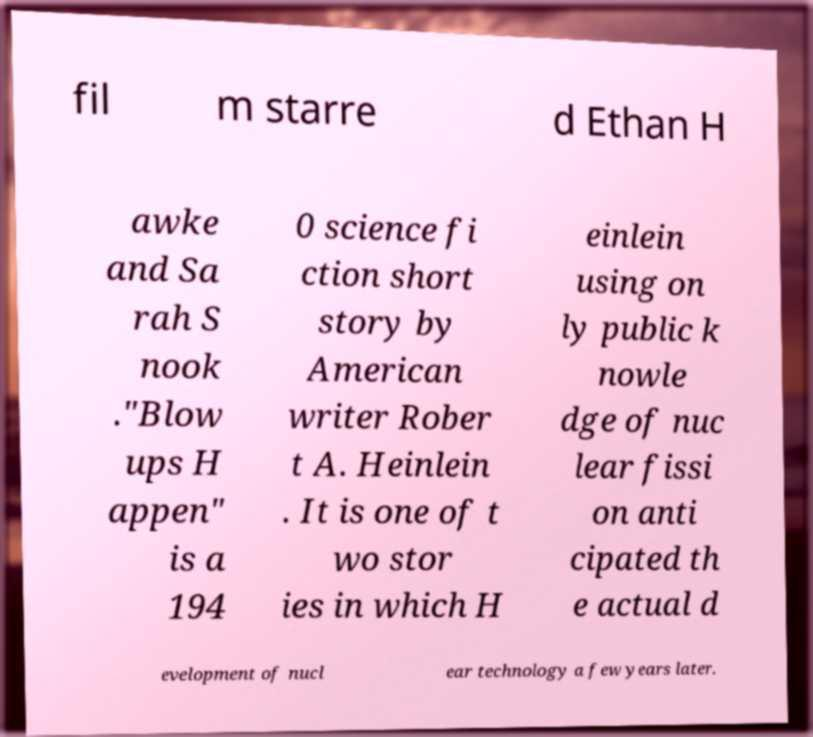Could you extract and type out the text from this image? fil m starre d Ethan H awke and Sa rah S nook ."Blow ups H appen" is a 194 0 science fi ction short story by American writer Rober t A. Heinlein . It is one of t wo stor ies in which H einlein using on ly public k nowle dge of nuc lear fissi on anti cipated th e actual d evelopment of nucl ear technology a few years later. 